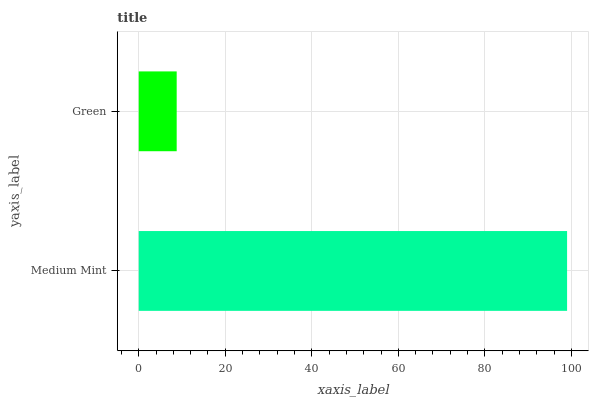Is Green the minimum?
Answer yes or no. Yes. Is Medium Mint the maximum?
Answer yes or no. Yes. Is Green the maximum?
Answer yes or no. No. Is Medium Mint greater than Green?
Answer yes or no. Yes. Is Green less than Medium Mint?
Answer yes or no. Yes. Is Green greater than Medium Mint?
Answer yes or no. No. Is Medium Mint less than Green?
Answer yes or no. No. Is Medium Mint the high median?
Answer yes or no. Yes. Is Green the low median?
Answer yes or no. Yes. Is Green the high median?
Answer yes or no. No. Is Medium Mint the low median?
Answer yes or no. No. 